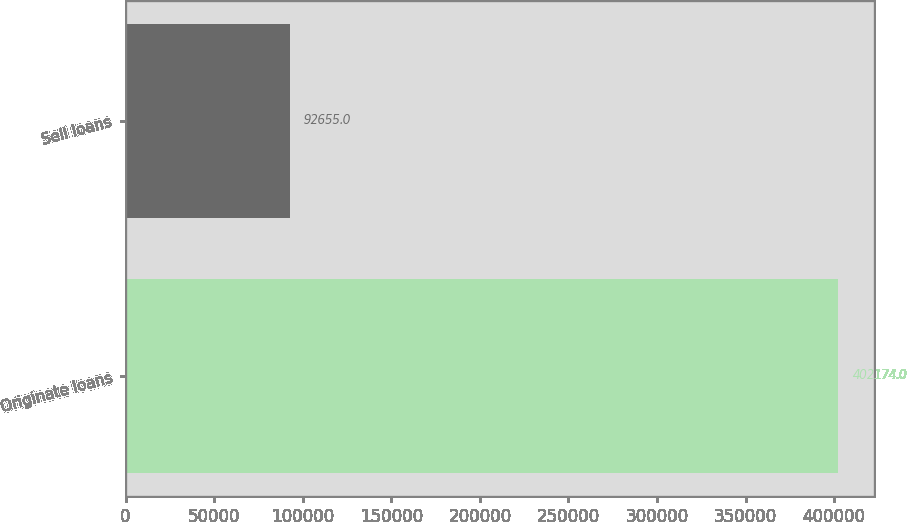<chart> <loc_0><loc_0><loc_500><loc_500><bar_chart><fcel>Originate loans<fcel>Sell loans<nl><fcel>402174<fcel>92655<nl></chart> 